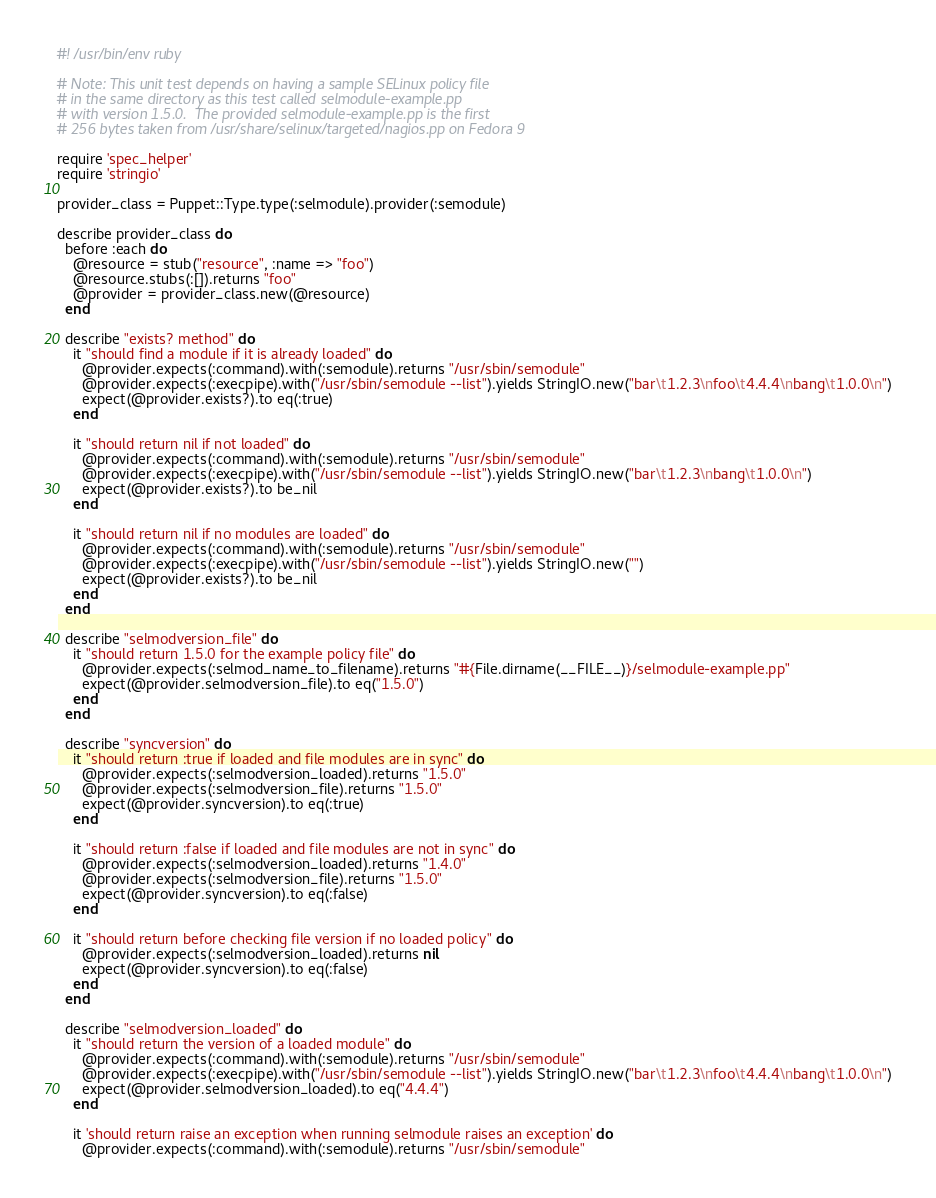<code> <loc_0><loc_0><loc_500><loc_500><_Ruby_>#! /usr/bin/env ruby

# Note: This unit test depends on having a sample SELinux policy file
# in the same directory as this test called selmodule-example.pp
# with version 1.5.0.  The provided selmodule-example.pp is the first
# 256 bytes taken from /usr/share/selinux/targeted/nagios.pp on Fedora 9

require 'spec_helper'
require 'stringio'

provider_class = Puppet::Type.type(:selmodule).provider(:semodule)

describe provider_class do
  before :each do
    @resource = stub("resource", :name => "foo")
    @resource.stubs(:[]).returns "foo"
    @provider = provider_class.new(@resource)
  end

  describe "exists? method" do
    it "should find a module if it is already loaded" do
      @provider.expects(:command).with(:semodule).returns "/usr/sbin/semodule"
      @provider.expects(:execpipe).with("/usr/sbin/semodule --list").yields StringIO.new("bar\t1.2.3\nfoo\t4.4.4\nbang\t1.0.0\n")
      expect(@provider.exists?).to eq(:true)
    end

    it "should return nil if not loaded" do
      @provider.expects(:command).with(:semodule).returns "/usr/sbin/semodule"
      @provider.expects(:execpipe).with("/usr/sbin/semodule --list").yields StringIO.new("bar\t1.2.3\nbang\t1.0.0\n")
      expect(@provider.exists?).to be_nil
    end

    it "should return nil if no modules are loaded" do
      @provider.expects(:command).with(:semodule).returns "/usr/sbin/semodule"
      @provider.expects(:execpipe).with("/usr/sbin/semodule --list").yields StringIO.new("")
      expect(@provider.exists?).to be_nil
    end
  end

  describe "selmodversion_file" do
    it "should return 1.5.0 for the example policy file" do
      @provider.expects(:selmod_name_to_filename).returns "#{File.dirname(__FILE__)}/selmodule-example.pp"
      expect(@provider.selmodversion_file).to eq("1.5.0")
    end
  end

  describe "syncversion" do
    it "should return :true if loaded and file modules are in sync" do
      @provider.expects(:selmodversion_loaded).returns "1.5.0"
      @provider.expects(:selmodversion_file).returns "1.5.0"
      expect(@provider.syncversion).to eq(:true)
    end

    it "should return :false if loaded and file modules are not in sync" do
      @provider.expects(:selmodversion_loaded).returns "1.4.0"
      @provider.expects(:selmodversion_file).returns "1.5.0"
      expect(@provider.syncversion).to eq(:false)
    end

    it "should return before checking file version if no loaded policy" do
      @provider.expects(:selmodversion_loaded).returns nil
      expect(@provider.syncversion).to eq(:false)
    end
  end

  describe "selmodversion_loaded" do
    it "should return the version of a loaded module" do
      @provider.expects(:command).with(:semodule).returns "/usr/sbin/semodule"
      @provider.expects(:execpipe).with("/usr/sbin/semodule --list").yields StringIO.new("bar\t1.2.3\nfoo\t4.4.4\nbang\t1.0.0\n")
      expect(@provider.selmodversion_loaded).to eq("4.4.4")
    end

    it 'should return raise an exception when running selmodule raises an exception' do
      @provider.expects(:command).with(:semodule).returns "/usr/sbin/semodule"</code> 